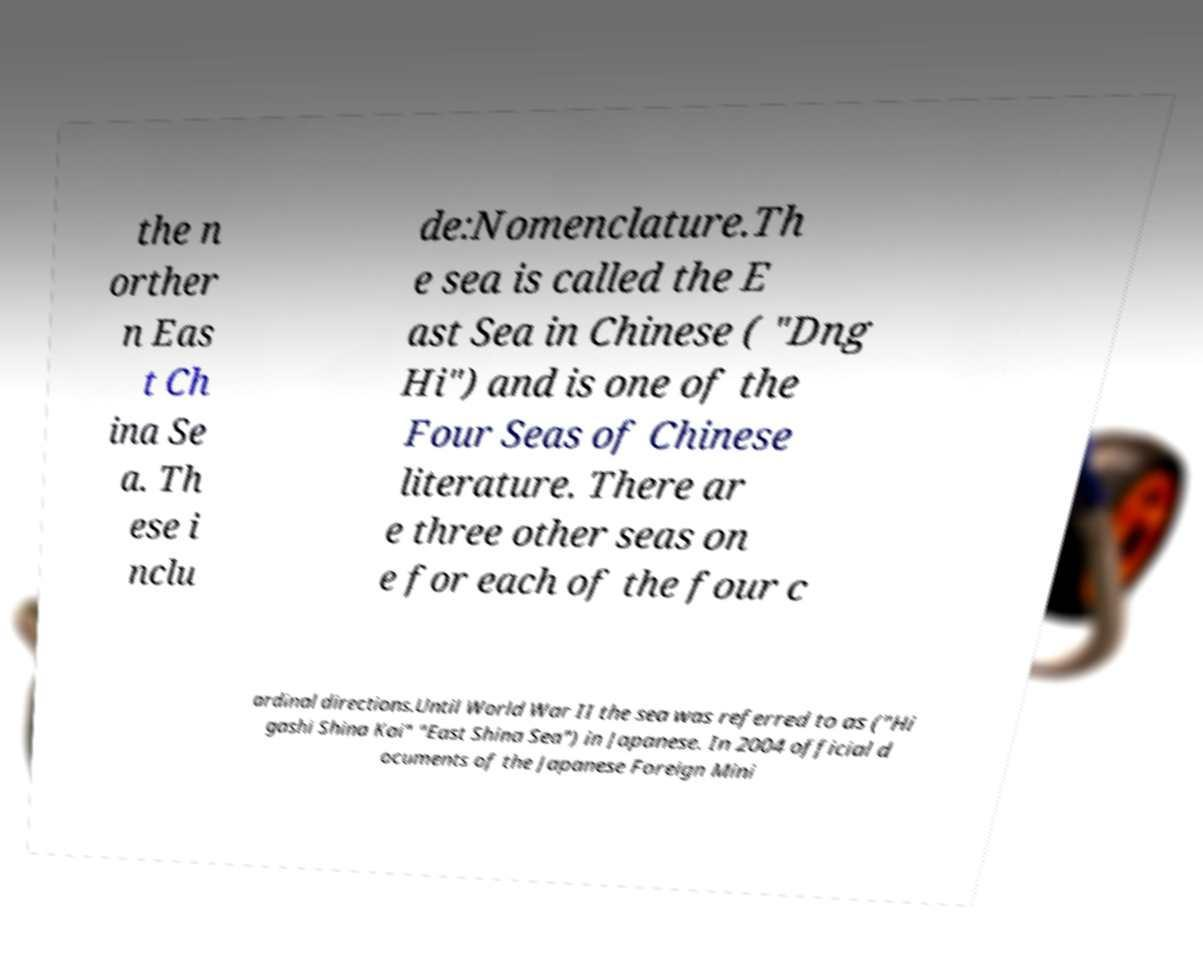There's text embedded in this image that I need extracted. Can you transcribe it verbatim? the n orther n Eas t Ch ina Se a. Th ese i nclu de:Nomenclature.Th e sea is called the E ast Sea in Chinese ( "Dng Hi") and is one of the Four Seas of Chinese literature. There ar e three other seas on e for each of the four c ardinal directions.Until World War II the sea was referred to as ("Hi gashi Shina Kai" "East Shina Sea") in Japanese. In 2004 official d ocuments of the Japanese Foreign Mini 